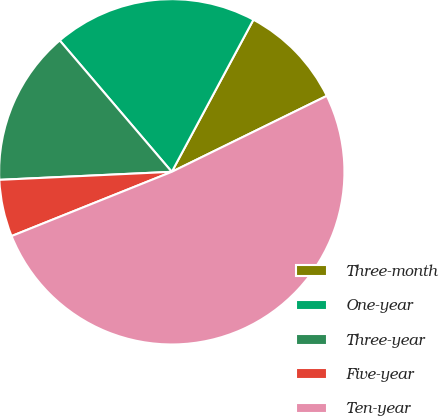<chart> <loc_0><loc_0><loc_500><loc_500><pie_chart><fcel>Three-month<fcel>One-year<fcel>Three-year<fcel>Five-year<fcel>Ten-year<nl><fcel>9.91%<fcel>19.08%<fcel>14.5%<fcel>5.33%<fcel>51.18%<nl></chart> 